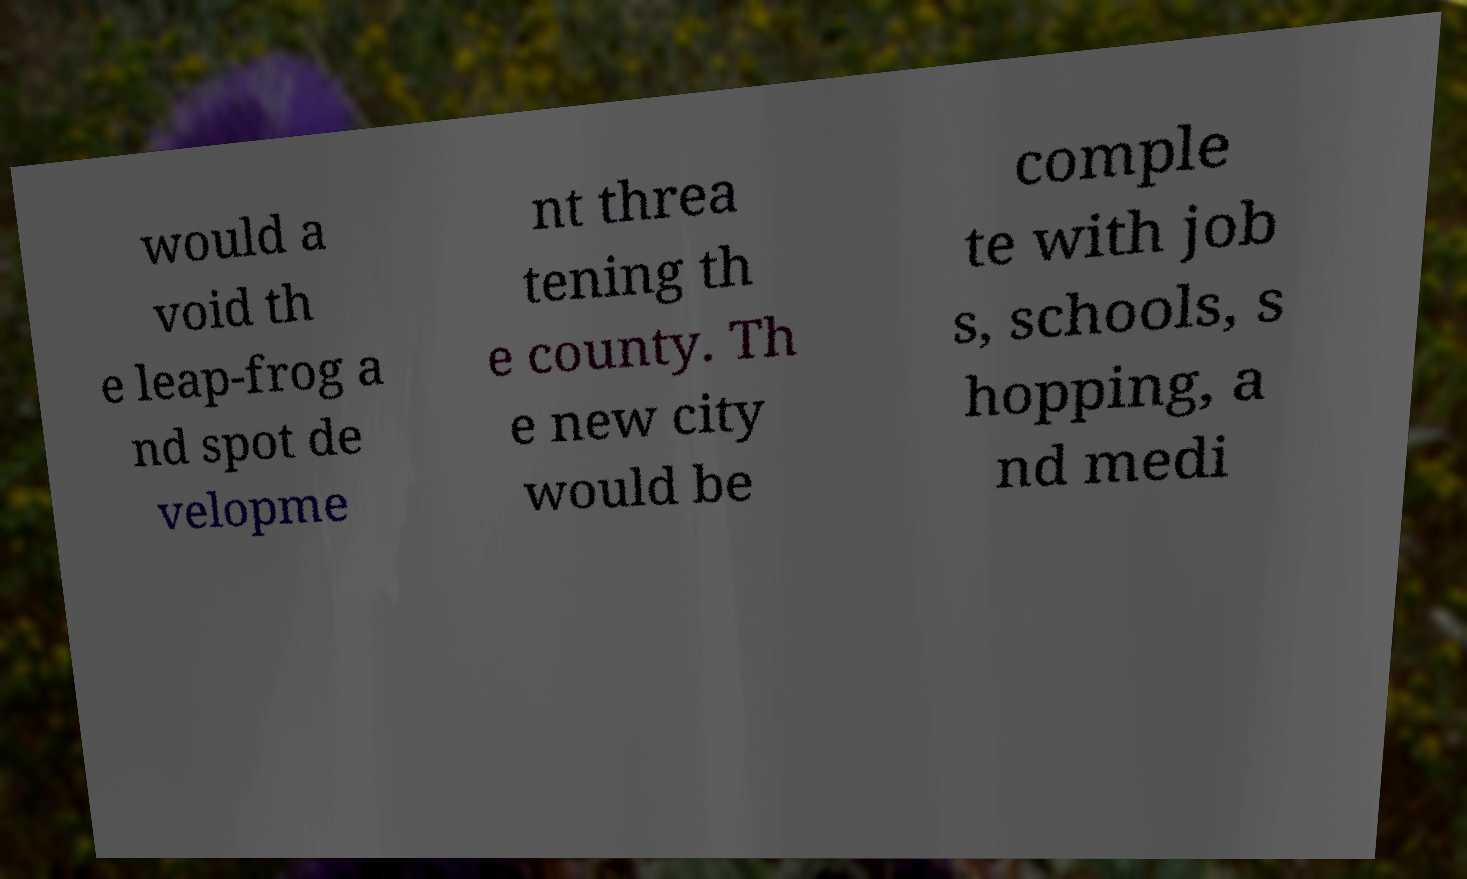Could you extract and type out the text from this image? would a void th e leap-frog a nd spot de velopme nt threa tening th e county. Th e new city would be comple te with job s, schools, s hopping, a nd medi 